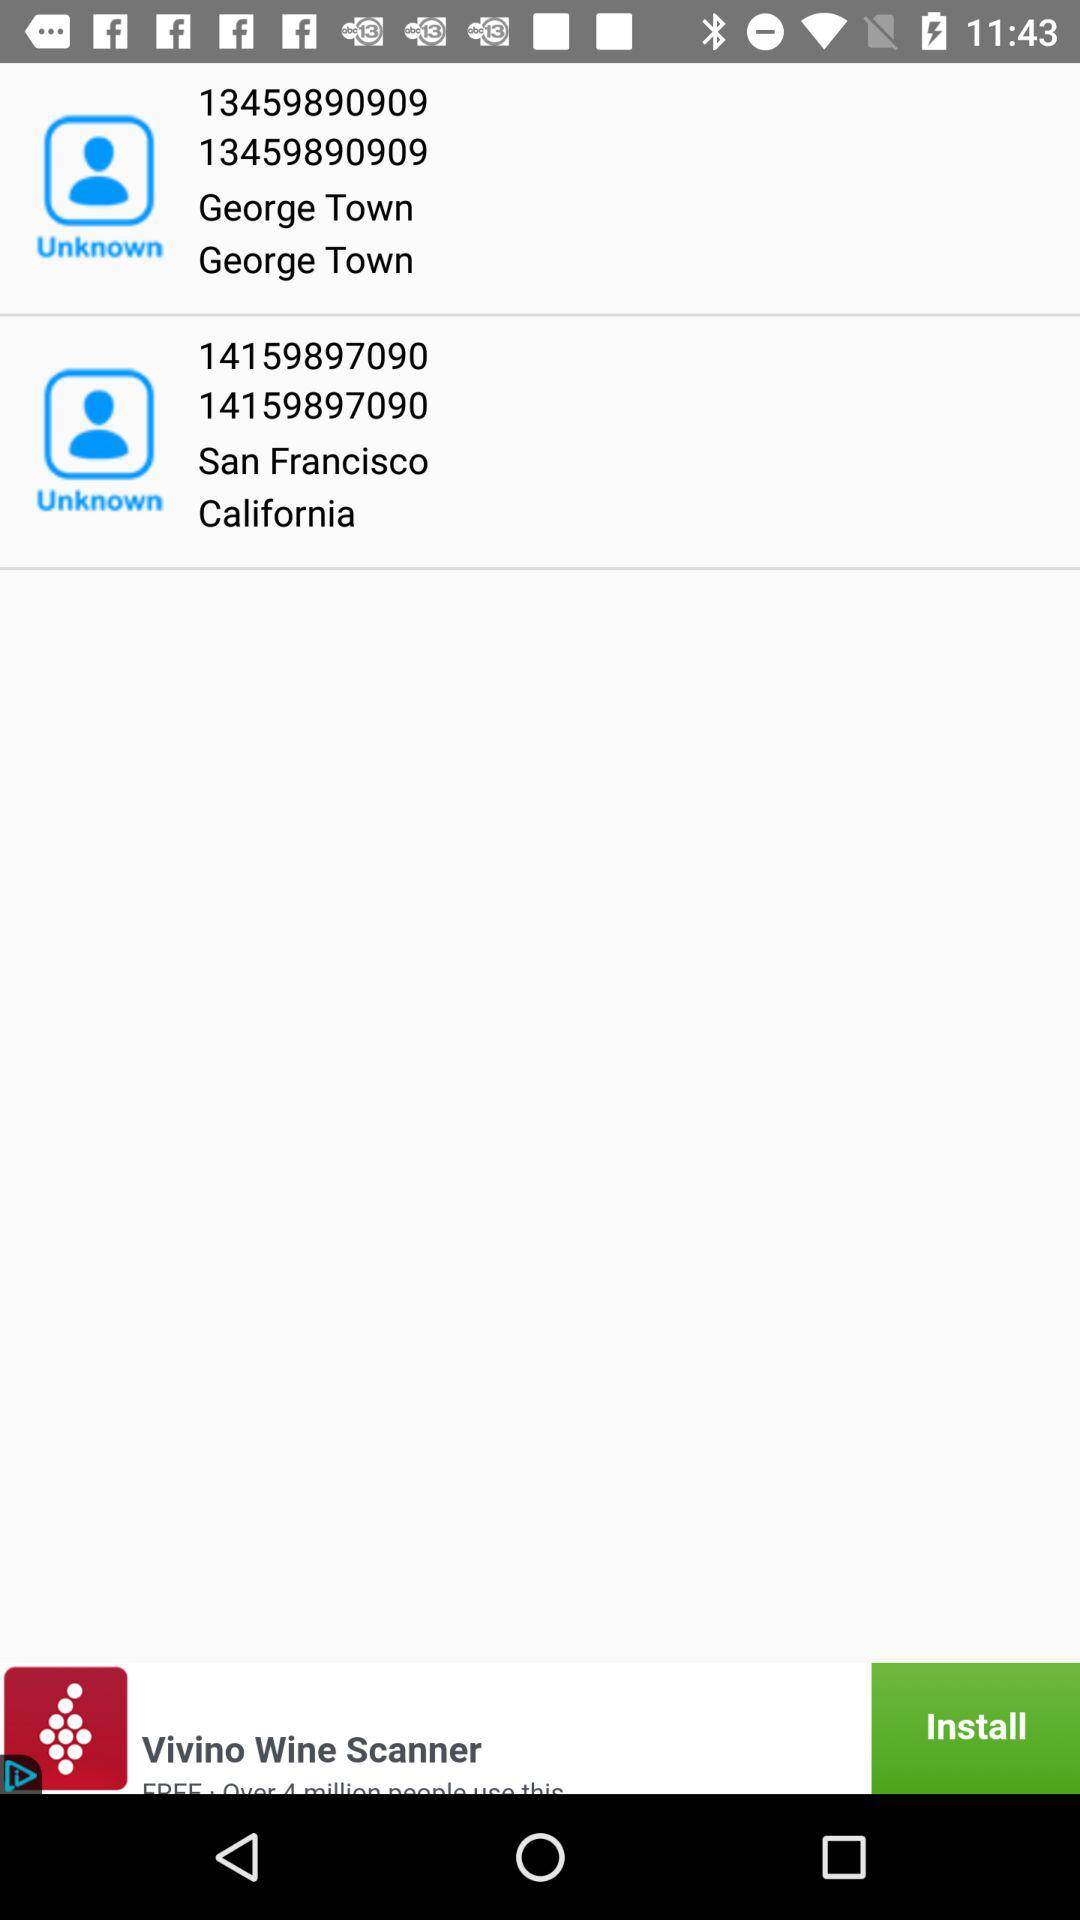What is the location of the number 14159897090? The location is San Francisco, California. 